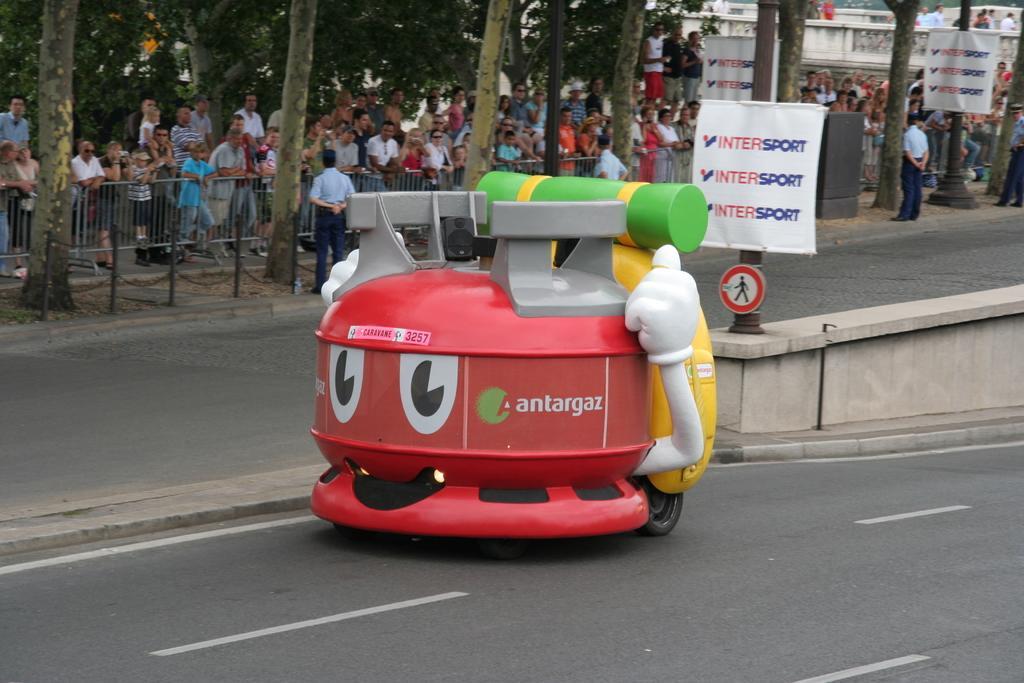Describe this image in one or two sentences. In this image we can see a vehicle on the road. In the background of the image there are people standing. There are trees. There is railing. There are safety poles. There are banners with some text on them. 